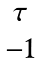Convert formula to latex. <formula><loc_0><loc_0><loc_500><loc_500>\begin{matrix} \tau \\ - 1 \end{matrix}</formula> 